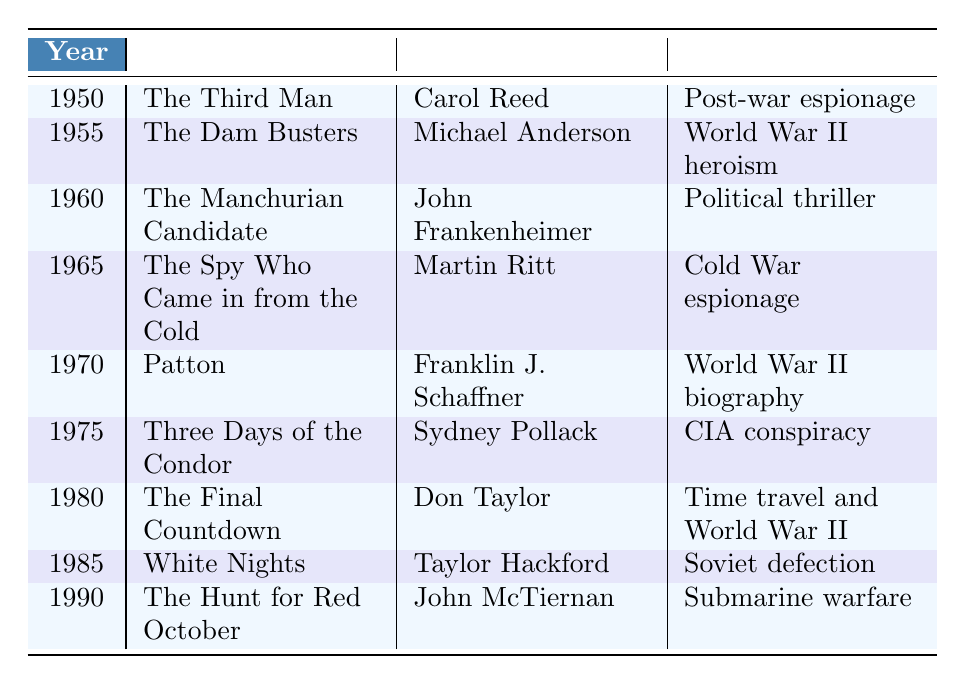What film was released in 1965? Referring to the table, in the row corresponding to the year 1965, the film listed is "The Spy Who Came in from the Cold."
Answer: The Spy Who Came in from the Cold Which director made "The Manchurian Candidate"? Looking at the entry for "The Manchurian Candidate," the director is listed as John Frankenheimer.
Answer: John Frankenheimer How many films were released in the 1970s? The table indicates that there are two films from the 1970s: "Patton" (1970) and "Three Days of the Condor" (1975). Therefore, the total count is 2.
Answer: 2 What is the theme of "White Nights"? By examining the row for "White Nights," the theme is identified as "Soviet defection."
Answer: Soviet defection Which film has a theme of CIA conspiracy? The table specifies that "Three Days of the Condor," released in 1975, corresponds to the theme of CIA conspiracy.
Answer: Three Days of the Condor What is the earliest film included in the table? The first entry in the table, corresponding to the year 1950, is "The Third Man," making it the earliest film listed.
Answer: The Third Man What was the last film released before 1991? The last entry before the year 1991 is "The Hunt for Red October," released in 1990.
Answer: The Hunt for Red October Is there a film from 1980 that involves World War II? The row for 1980 indicates the film "The Final Countdown," which has the theme of time travel and World War II, confirming the statement is true.
Answer: Yes How many films in the table are based on actual historical events? The films "The Dam Busters" and "Patton" can be classified as based on actual historical events. Therefore, there are 2 films fitting this criterion.
Answer: 2 Which decade had the most films focused on Cold War themes? By reviewing the themes, "The Spy Who Came in from the Cold" (1965) and "Three Days of the Condor" (1975) align with Cold War themes. Thus, the 1960s and 1970s both feature 2 films each. Comparing with other decades, no other decade has more, so the 1960s and 1970s share the title.
Answer: 1960s and 1970s What is the average year of release for the films listed? To find the average, sum the years: (1950 + 1955 + 1960 + 1965 + 1970 + 1975 + 1980 + 1985 + 1990) = 1975. Divide by the number of films (9), which is 1975/9 ≈ 219.44. Thus, the average release year is approximately 1975.
Answer: 1975 